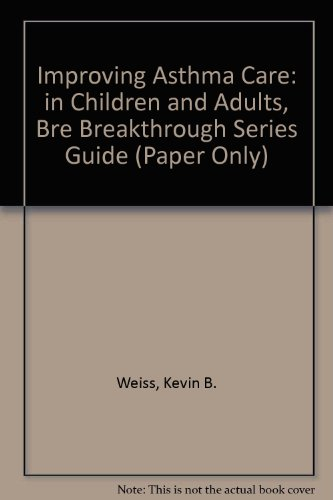Who wrote this book?
Answer the question using a single word or phrase. Weiss What is the title of this book? Improving Asthma Care in Children and Adults What is the genre of this book? Health, Fitness & Dieting Is this a fitness book? Yes Is this a judicial book? No 